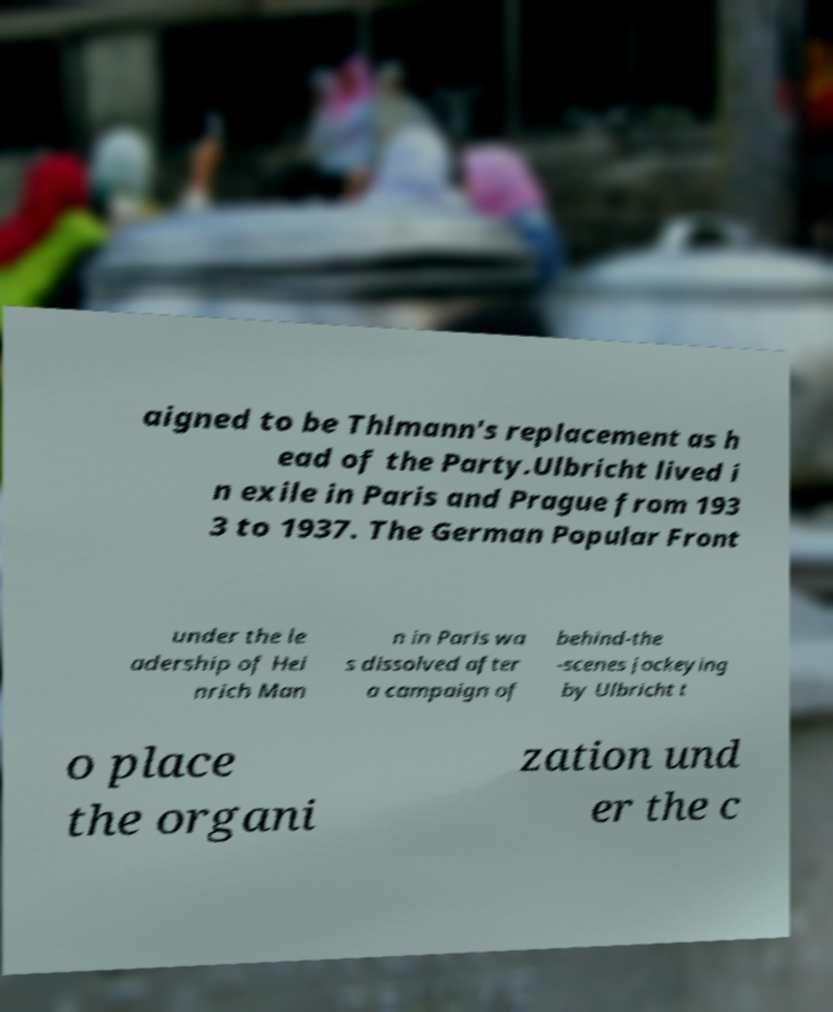I need the written content from this picture converted into text. Can you do that? aigned to be Thlmann's replacement as h ead of the Party.Ulbricht lived i n exile in Paris and Prague from 193 3 to 1937. The German Popular Front under the le adership of Hei nrich Man n in Paris wa s dissolved after a campaign of behind-the -scenes jockeying by Ulbricht t o place the organi zation und er the c 